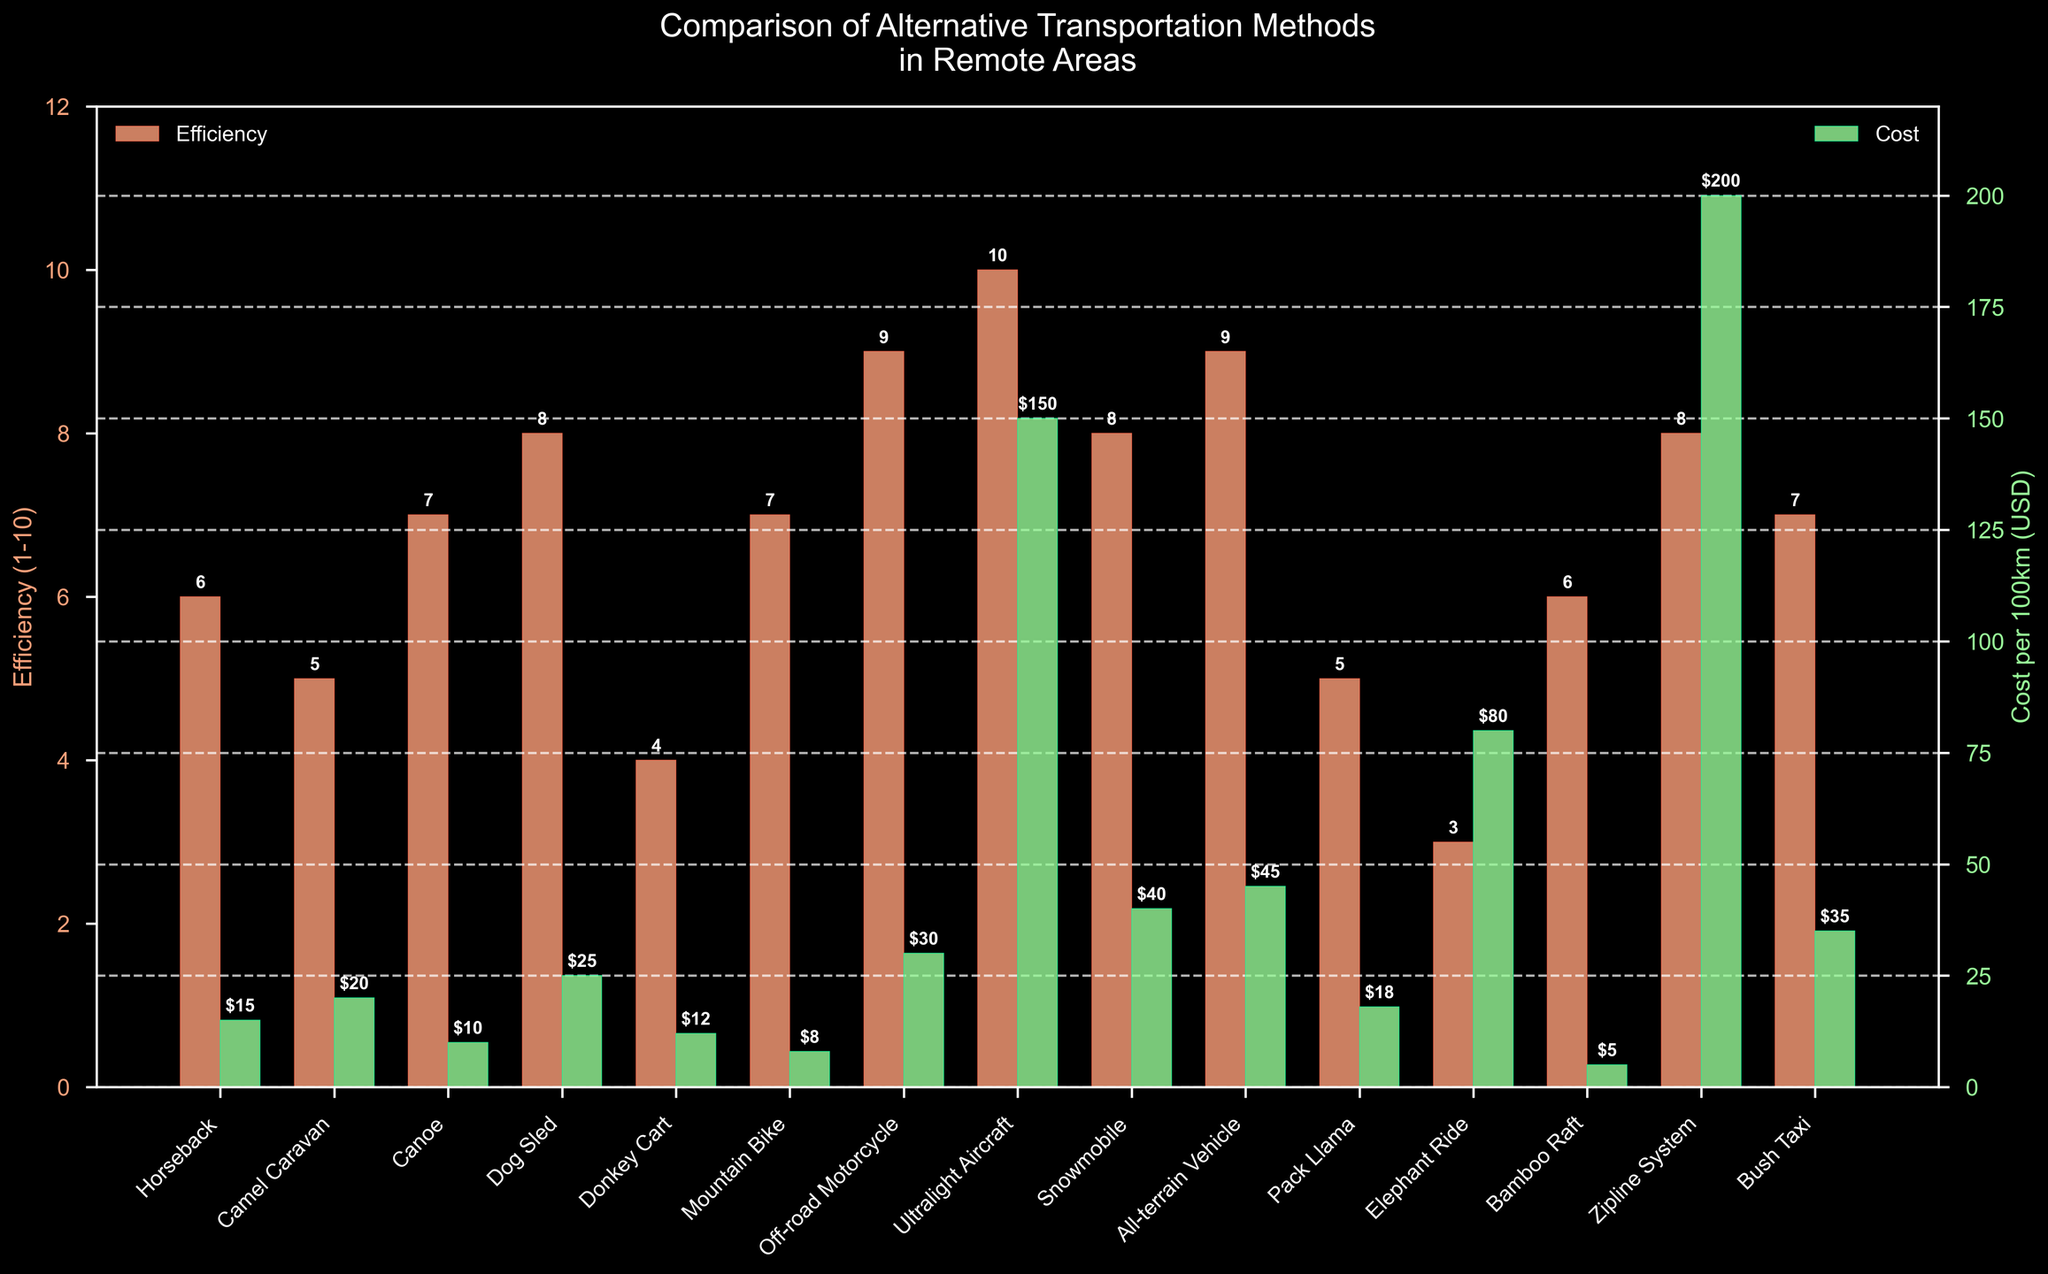Which transportation method has the highest efficiency? According to the efficiency bar heights, Ultralight Aircraft has the highest value.
Answer: Ultralight Aircraft Which transportation method has the lowest cost per 100km? By comparing the heights of the green bars representing cost, Bamboo Raft has the lowest cost.
Answer: Bamboo Raft What is the total cost per 100km for Dog Sled, Snowmobile, and Bush Taxi combined? Add the values of the costs per 100km for Dog Sled (25 USD), Snowmobile (40 USD), and Bush Taxi (35 USD): 25 + 40 + 35 = 100 USD.
Answer: 100 USD Which is more efficient, Canoe or Donkey Cart? Comparing the orange bar heights, Canoe (7) is higher than Donkey Cart (4).
Answer: Canoe What is the average cost per 100km for transportation methods that have an efficiency greater than 7? The methods with efficiency >7 are Off-road Motorcycle (30 USD), Ultralight Aircraft (150 USD), Snowmobile (40 USD), and Zipline System (200 USD). Average = (30 + 150 + 40 + 200) / 4 = 420 / 4 = 105 USD.
Answer: 105 USD Are the efficiency and cost per 100km correlated? Observing the bars, there is no consistent pattern suggesting correlation; methods with high efficiency can have either low or high cost.
Answer: No How many transportation methods have an efficiency of 7? Identify bars with a height of 7 in the Efficiency series: Canoe, Mountain Bike, and Bush Taxi.
Answer: 3 What is the difference in cost per 100km between the most expensive and the cheapest method? The most expensive method is Zipline System (200 USD) and the cheapest is Bamboo Raft (5 USD). Difference = 200 - 5 = 195 USD.
Answer: 195 USD 